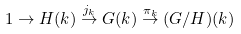Convert formula to latex. <formula><loc_0><loc_0><loc_500><loc_500>1 \rightarrow H ( k ) \stackrel { j _ { k } } { \rightarrow } G ( k ) \stackrel { \pi _ { k } } { \rightarrow } ( G / H ) ( k )</formula> 